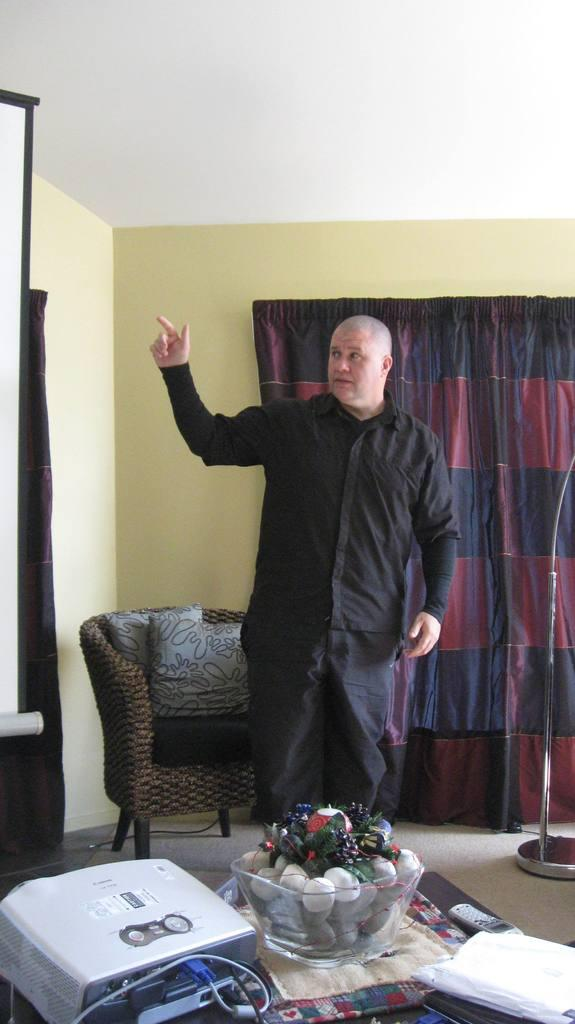What is the man doing in the image? The man is standing in the image. What is located near the man in the image? There is a chair with pillows and a bowl in the image. What type of device is present in the image? There is a device in the image. What is the background of the image like? There is a wall and curtains in the background of the image. What type of government is depicted in the image? There is no depiction of a government in the image; it features a man, a chair with pillows, a bowl, a device, a mobile, a wall, and curtains. How many babies are visible in the image? There are no babies present in the image. 